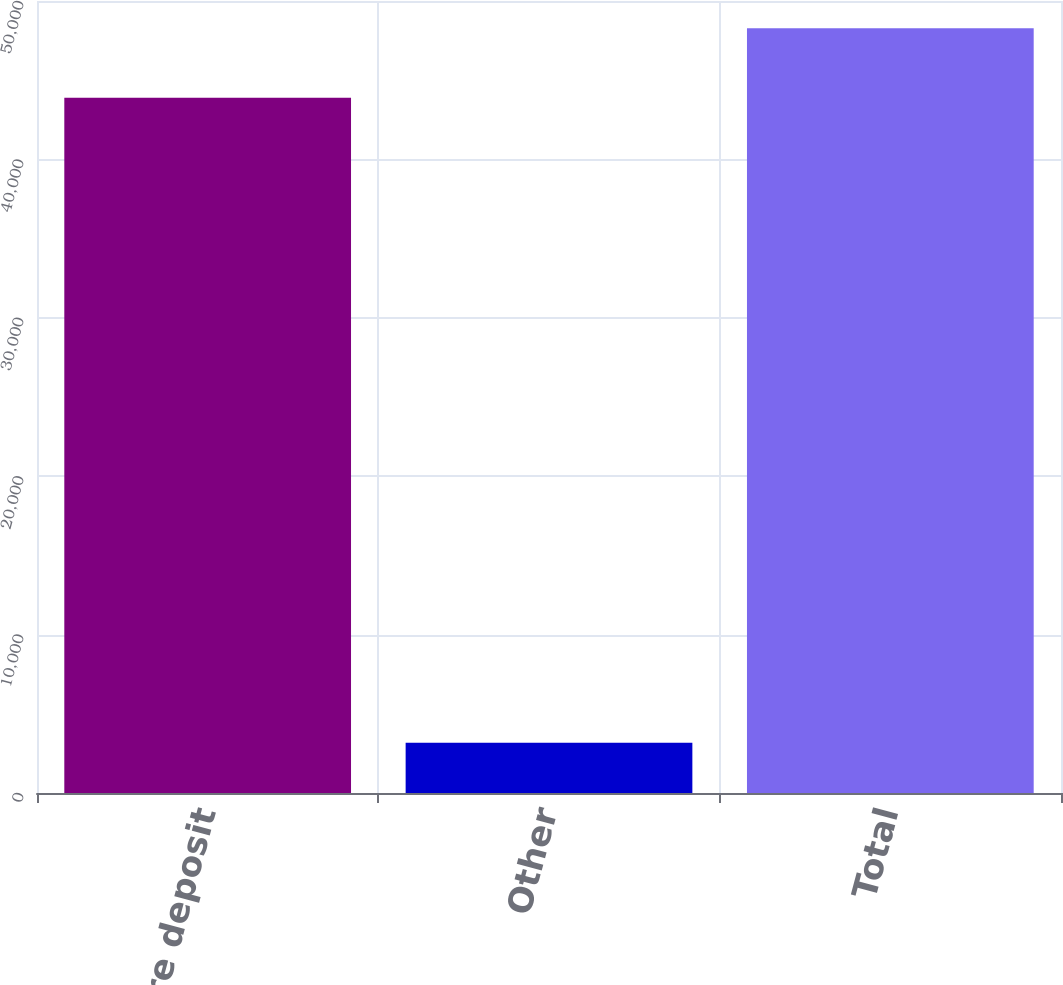Convert chart. <chart><loc_0><loc_0><loc_500><loc_500><bar_chart><fcel>Core deposit<fcel>Other<fcel>Total<nl><fcel>43887<fcel>3180<fcel>48275.7<nl></chart> 